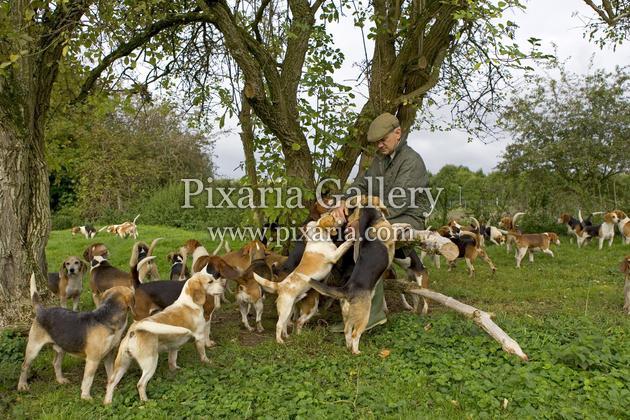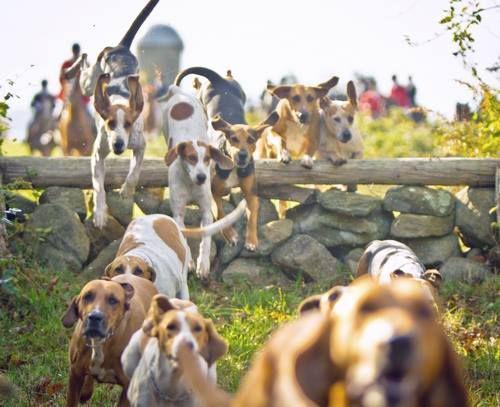The first image is the image on the left, the second image is the image on the right. Evaluate the accuracy of this statement regarding the images: "An image shows a man in white pants astride a horse in the foreground, and includes someone in a red jacket somewhere in the scene.". Is it true? Answer yes or no. No. 